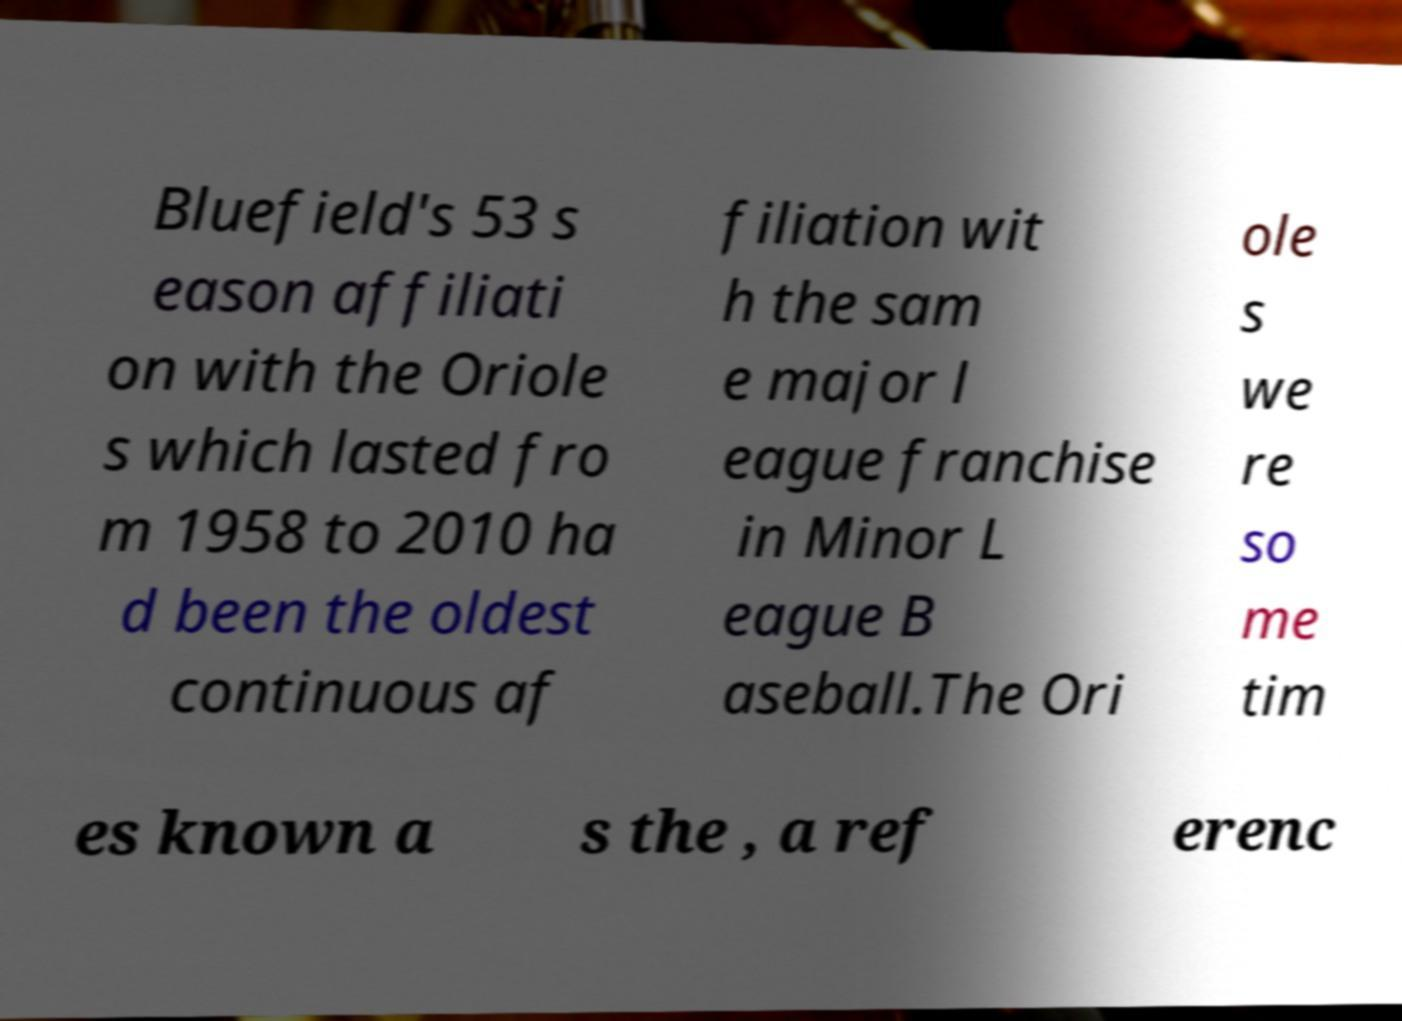Please read and relay the text visible in this image. What does it say? Bluefield's 53 s eason affiliati on with the Oriole s which lasted fro m 1958 to 2010 ha d been the oldest continuous af filiation wit h the sam e major l eague franchise in Minor L eague B aseball.The Ori ole s we re so me tim es known a s the , a ref erenc 